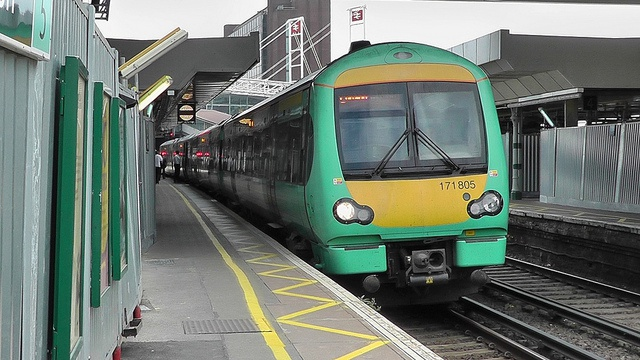Describe the objects in this image and their specific colors. I can see train in lightgray, black, gray, teal, and tan tones, people in lightgray, black, gray, and darkgray tones, people in lightgray, black, gray, and darkgray tones, and people in black, gray, and lightgray tones in this image. 